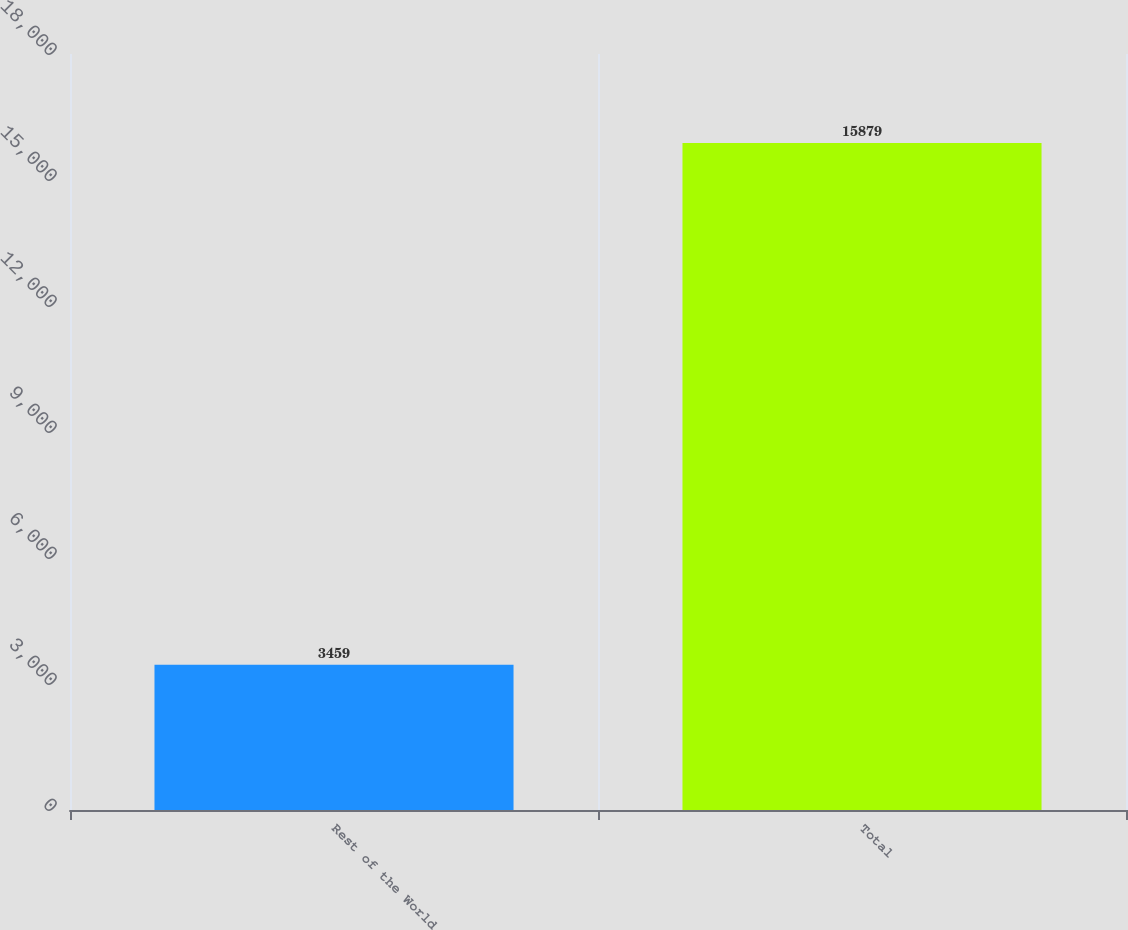<chart> <loc_0><loc_0><loc_500><loc_500><bar_chart><fcel>Rest of the World<fcel>Total<nl><fcel>3459<fcel>15879<nl></chart> 